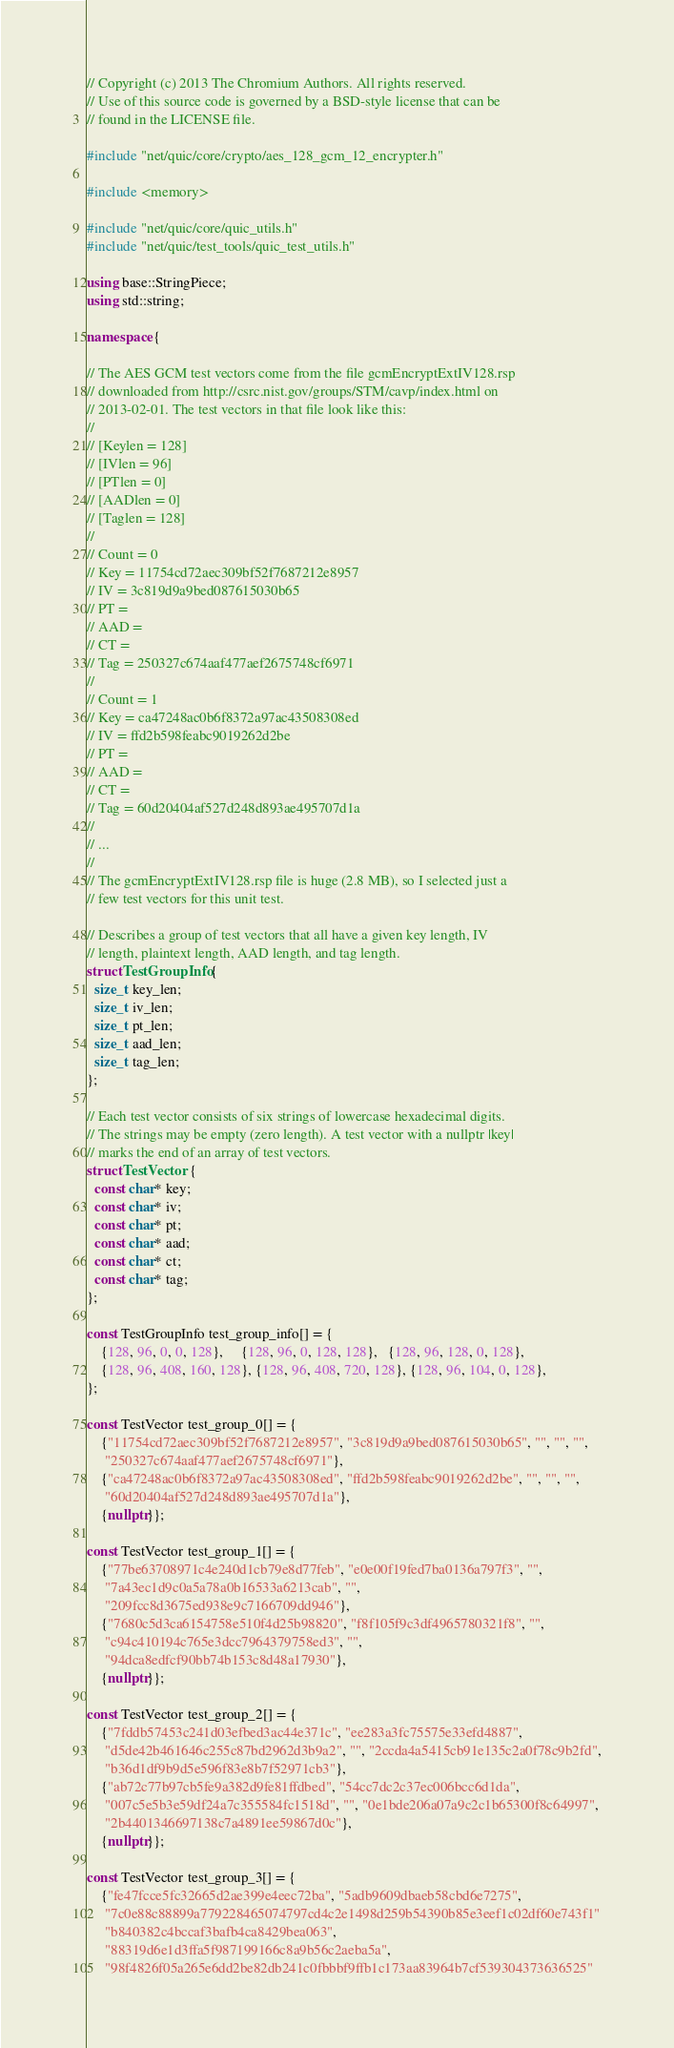<code> <loc_0><loc_0><loc_500><loc_500><_C++_>// Copyright (c) 2013 The Chromium Authors. All rights reserved.
// Use of this source code is governed by a BSD-style license that can be
// found in the LICENSE file.

#include "net/quic/core/crypto/aes_128_gcm_12_encrypter.h"

#include <memory>

#include "net/quic/core/quic_utils.h"
#include "net/quic/test_tools/quic_test_utils.h"

using base::StringPiece;
using std::string;

namespace {

// The AES GCM test vectors come from the file gcmEncryptExtIV128.rsp
// downloaded from http://csrc.nist.gov/groups/STM/cavp/index.html on
// 2013-02-01. The test vectors in that file look like this:
//
// [Keylen = 128]
// [IVlen = 96]
// [PTlen = 0]
// [AADlen = 0]
// [Taglen = 128]
//
// Count = 0
// Key = 11754cd72aec309bf52f7687212e8957
// IV = 3c819d9a9bed087615030b65
// PT =
// AAD =
// CT =
// Tag = 250327c674aaf477aef2675748cf6971
//
// Count = 1
// Key = ca47248ac0b6f8372a97ac43508308ed
// IV = ffd2b598feabc9019262d2be
// PT =
// AAD =
// CT =
// Tag = 60d20404af527d248d893ae495707d1a
//
// ...
//
// The gcmEncryptExtIV128.rsp file is huge (2.8 MB), so I selected just a
// few test vectors for this unit test.

// Describes a group of test vectors that all have a given key length, IV
// length, plaintext length, AAD length, and tag length.
struct TestGroupInfo {
  size_t key_len;
  size_t iv_len;
  size_t pt_len;
  size_t aad_len;
  size_t tag_len;
};

// Each test vector consists of six strings of lowercase hexadecimal digits.
// The strings may be empty (zero length). A test vector with a nullptr |key|
// marks the end of an array of test vectors.
struct TestVector {
  const char* key;
  const char* iv;
  const char* pt;
  const char* aad;
  const char* ct;
  const char* tag;
};

const TestGroupInfo test_group_info[] = {
    {128, 96, 0, 0, 128},     {128, 96, 0, 128, 128},   {128, 96, 128, 0, 128},
    {128, 96, 408, 160, 128}, {128, 96, 408, 720, 128}, {128, 96, 104, 0, 128},
};

const TestVector test_group_0[] = {
    {"11754cd72aec309bf52f7687212e8957", "3c819d9a9bed087615030b65", "", "", "",
     "250327c674aaf477aef2675748cf6971"},
    {"ca47248ac0b6f8372a97ac43508308ed", "ffd2b598feabc9019262d2be", "", "", "",
     "60d20404af527d248d893ae495707d1a"},
    {nullptr}};

const TestVector test_group_1[] = {
    {"77be63708971c4e240d1cb79e8d77feb", "e0e00f19fed7ba0136a797f3", "",
     "7a43ec1d9c0a5a78a0b16533a6213cab", "",
     "209fcc8d3675ed938e9c7166709dd946"},
    {"7680c5d3ca6154758e510f4d25b98820", "f8f105f9c3df4965780321f8", "",
     "c94c410194c765e3dcc7964379758ed3", "",
     "94dca8edfcf90bb74b153c8d48a17930"},
    {nullptr}};

const TestVector test_group_2[] = {
    {"7fddb57453c241d03efbed3ac44e371c", "ee283a3fc75575e33efd4887",
     "d5de42b461646c255c87bd2962d3b9a2", "", "2ccda4a5415cb91e135c2a0f78c9b2fd",
     "b36d1df9b9d5e596f83e8b7f52971cb3"},
    {"ab72c77b97cb5fe9a382d9fe81ffdbed", "54cc7dc2c37ec006bcc6d1da",
     "007c5e5b3e59df24a7c355584fc1518d", "", "0e1bde206a07a9c2c1b65300f8c64997",
     "2b4401346697138c7a4891ee59867d0c"},
    {nullptr}};

const TestVector test_group_3[] = {
    {"fe47fcce5fc32665d2ae399e4eec72ba", "5adb9609dbaeb58cbd6e7275",
     "7c0e88c88899a779228465074797cd4c2e1498d259b54390b85e3eef1c02df60e743f1"
     "b840382c4bccaf3bafb4ca8429bea063",
     "88319d6e1d3ffa5f987199166c8a9b56c2aeba5a",
     "98f4826f05a265e6dd2be82db241c0fbbbf9ffb1c173aa83964b7cf539304373636525"</code> 